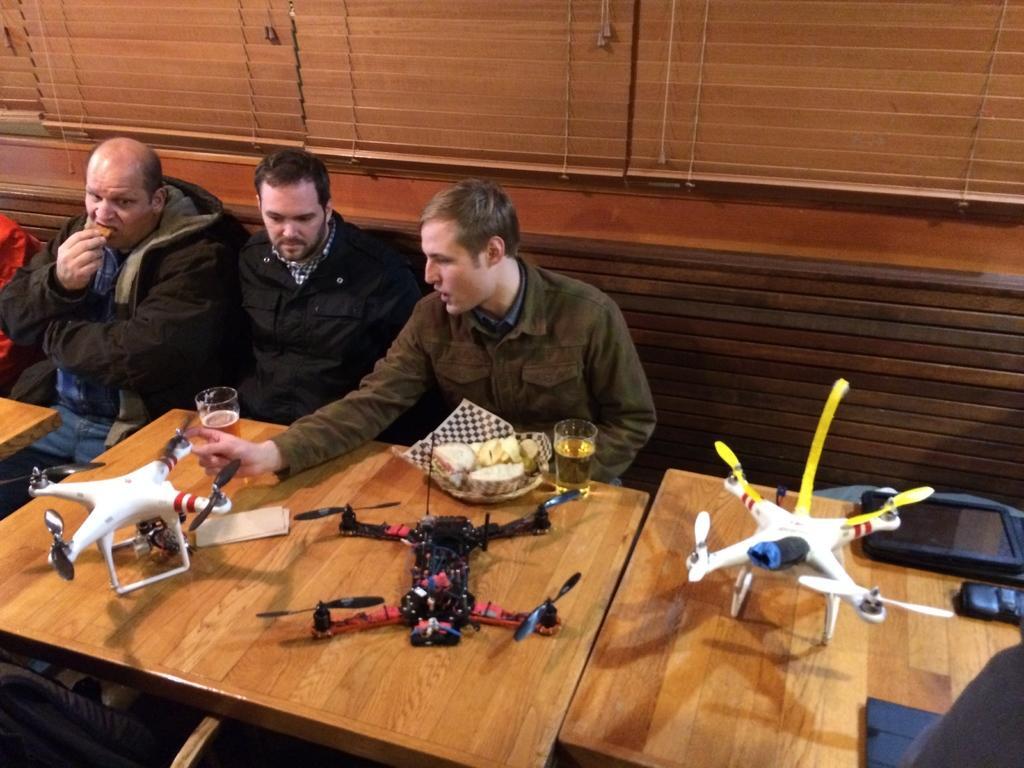Describe this image in one or two sentences. In the image there are tables with drones, glasses and some other items. Behind the table there are three men sitting on the bench. Behind them there are curtains of windows. 